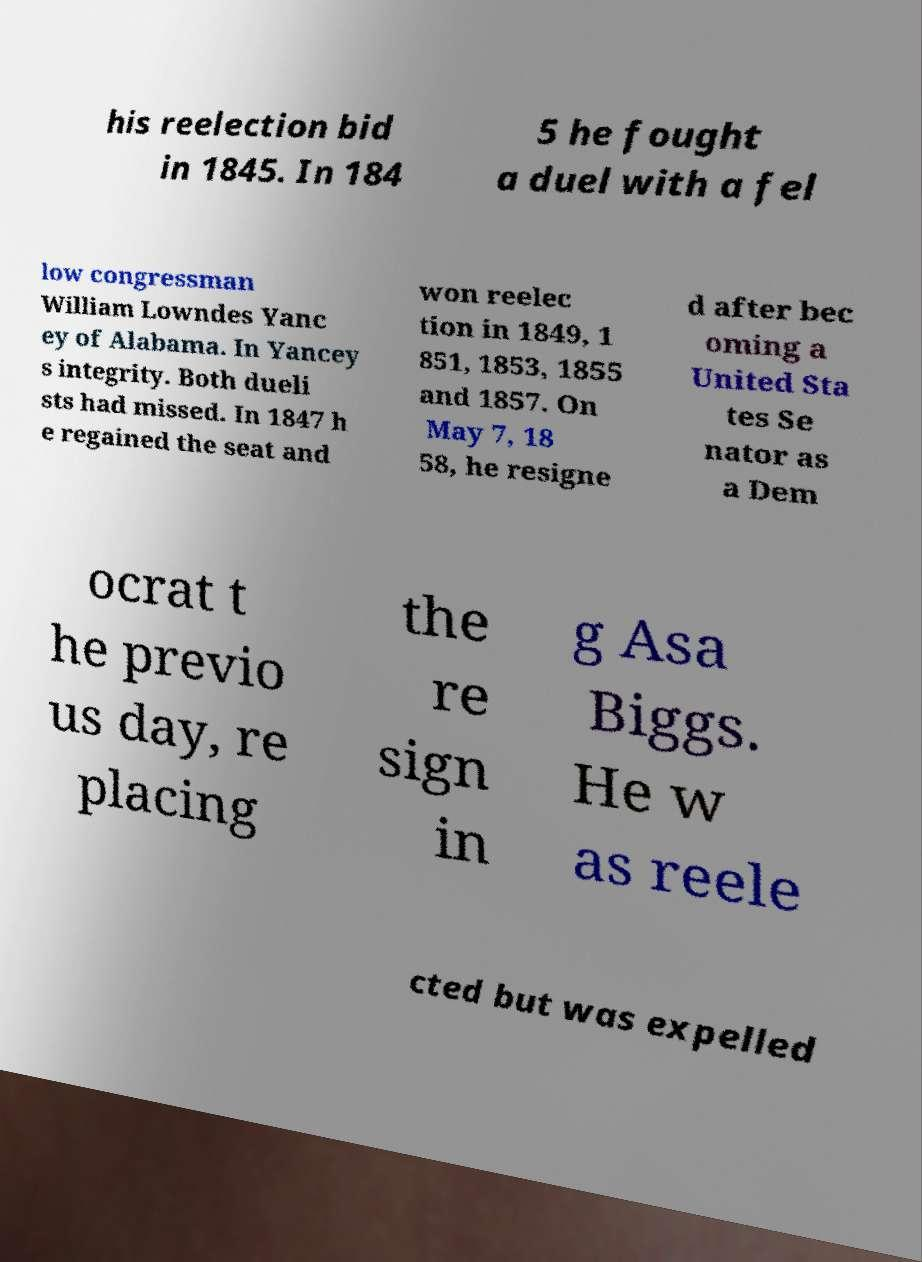Could you assist in decoding the text presented in this image and type it out clearly? his reelection bid in 1845. In 184 5 he fought a duel with a fel low congressman William Lowndes Yanc ey of Alabama. In Yancey s integrity. Both dueli sts had missed. In 1847 h e regained the seat and won reelec tion in 1849, 1 851, 1853, 1855 and 1857. On May 7, 18 58, he resigne d after bec oming a United Sta tes Se nator as a Dem ocrat t he previo us day, re placing the re sign in g Asa Biggs. He w as reele cted but was expelled 